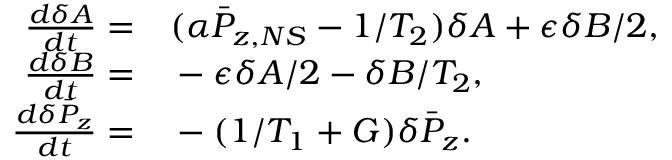<formula> <loc_0><loc_0><loc_500><loc_500>\begin{array} { r l } { \frac { d \delta A } { d t } = } & ( \alpha \bar { P } _ { z , N S } - 1 / T _ { 2 } ) \delta A + \epsilon \delta B / 2 , } \\ { \frac { d \delta B } { d t } = } & - \epsilon \delta A / 2 - \delta B / T _ { 2 } , } \\ { \frac { d \delta \bar { P } _ { z } } { d t } = } & - ( 1 / T _ { 1 } + G ) \delta \bar { P } _ { z } . } \end{array}</formula> 